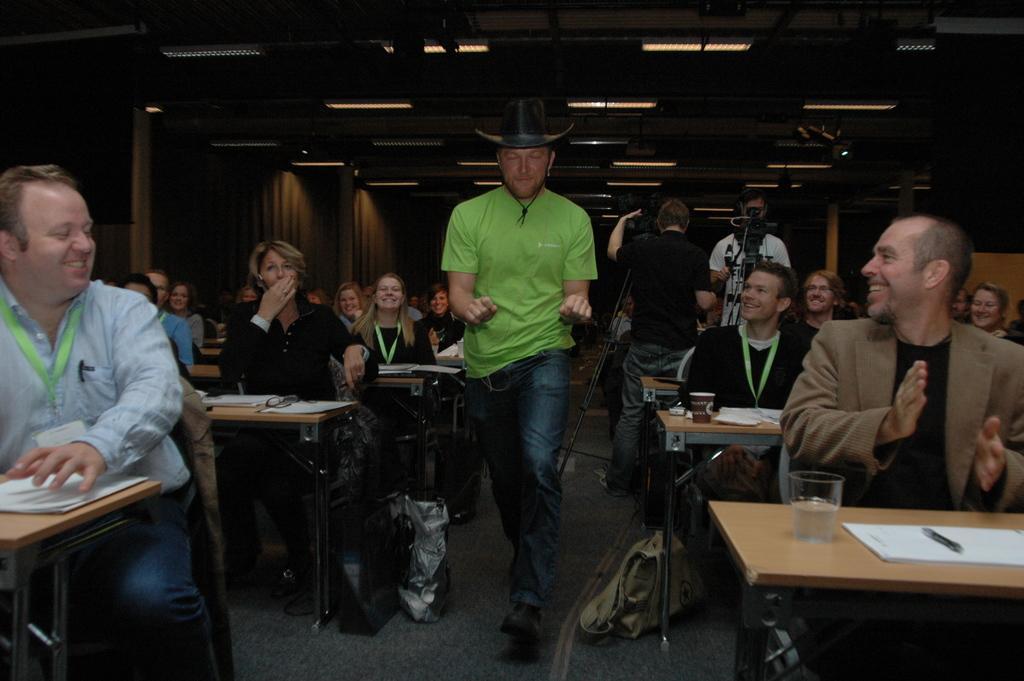Describe this image in one or two sentences. In the image we can see there is a man who is standing on the floor and either side of the man there are people who are sitting on the benches and over here there are two men who are standing. A man here holding a video camera and it's with a stand. 